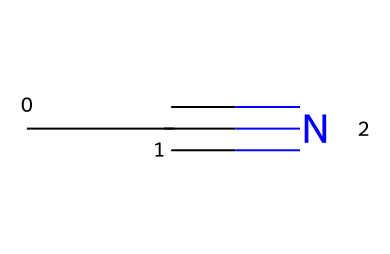How many carbon atoms are in acetonitrile? The SMILES representation CC#N indicates the presence of two carbon atoms (C) before the triple bond with nitrogen (N). Each 'C' represents one carbon atom.
Answer: 2 What is the functional group present in acetonitrile? Acetonitrile contains a nitrile functional group, identified by the presence of the triple bond between carbon and nitrogen at the end of the molecule. The 'C#N' notation indicates this specific functional group.
Answer: nitrile How are carbon and nitrogen atoms bonded in acetonitrile? In acetonitrile, the carbon atoms are bonded in a linear arrangement, with a triple bond between the last carbon (the second one) and the nitrogen atom. This is indicative of a strong bond typically found in nitriles.
Answer: triple bond What is the total number of atoms in acetonitrile? There are two carbon atoms and one nitrogen atom in acetonitrile, totaling three atoms. This is a straightforward addition of the atoms represented in the SMILES notation and reinforces the molecular composition of the chemical.
Answer: 3 Which type of compound does acetonitrile represent? Acetonitrile is classified as a nitrile compound based on its structure, particularly the carbon-nitrogen triple bond. Nitriles specifically contain this feature, which distinguishes them from other compound types.
Answer: nitrile What is the molecular formula for acetonitrile? By interpreting the SMILES CC#N, we can deduce that the molecular formula is C2H3N. This represents two carbon atoms, three hydrogen atoms, and one nitrogen atom, which can be derived directly from the structure.
Answer: C2H3N 